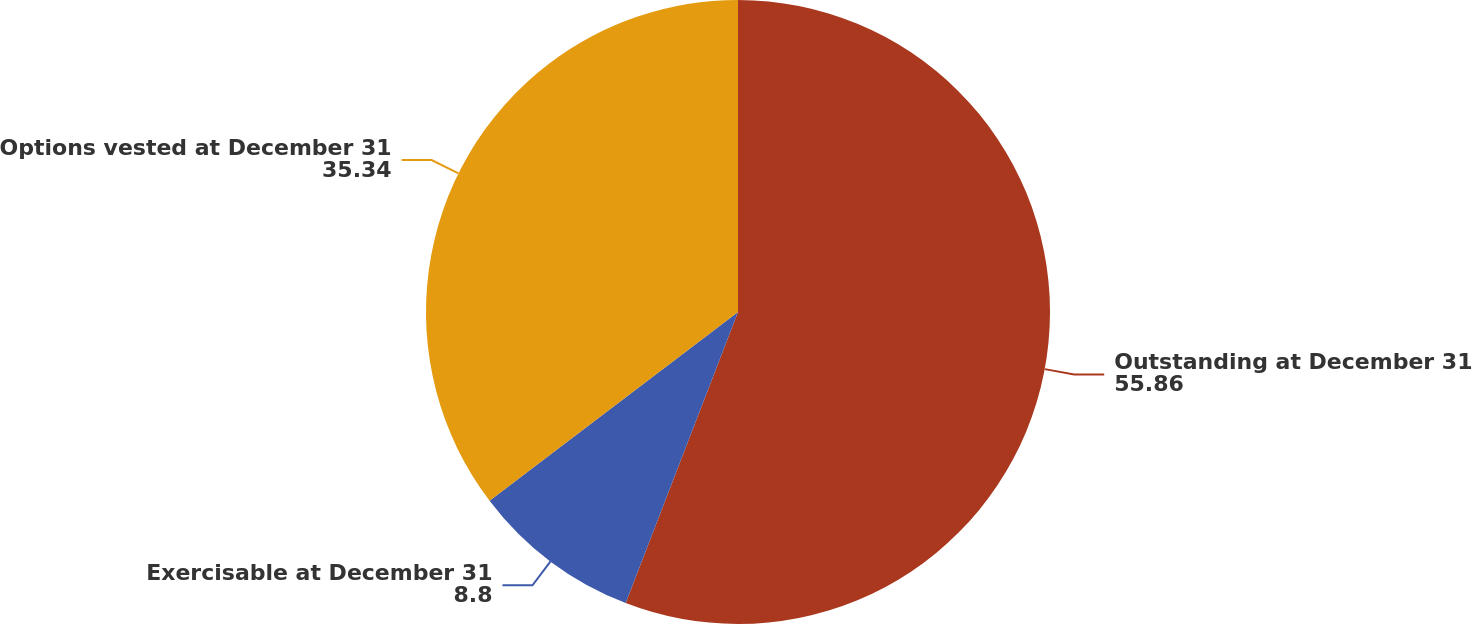Convert chart. <chart><loc_0><loc_0><loc_500><loc_500><pie_chart><fcel>Outstanding at December 31<fcel>Exercisable at December 31<fcel>Options vested at December 31<nl><fcel>55.86%<fcel>8.8%<fcel>35.34%<nl></chart> 